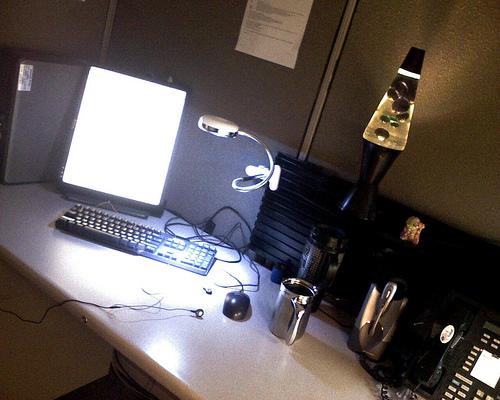What is the thing with bubbles in it?
Write a very short answer. Lava lamp. What is the color of the mouse?
Be succinct. Black. Is there a mug with something in it?
Short answer required. Yes. 